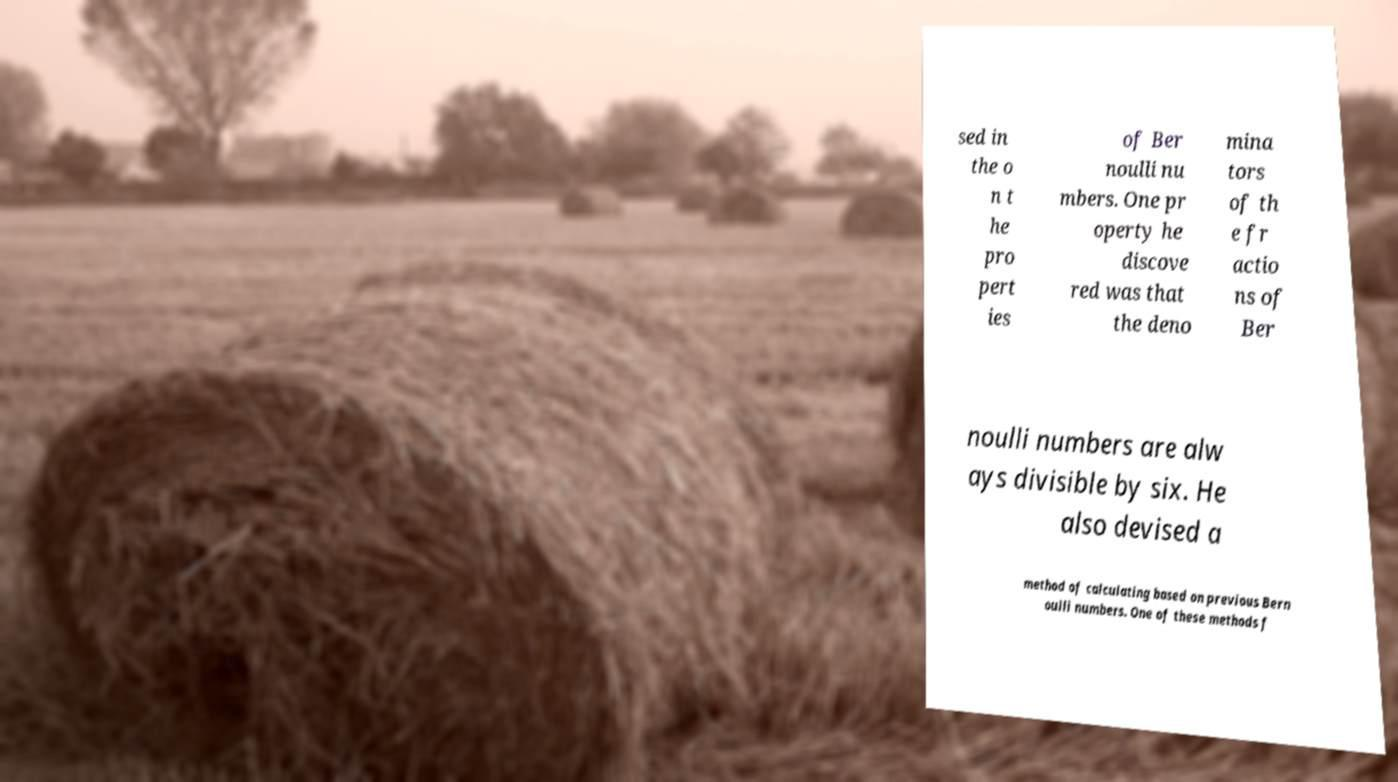I need the written content from this picture converted into text. Can you do that? sed in the o n t he pro pert ies of Ber noulli nu mbers. One pr operty he discove red was that the deno mina tors of th e fr actio ns of Ber noulli numbers are alw ays divisible by six. He also devised a method of calculating based on previous Bern oulli numbers. One of these methods f 